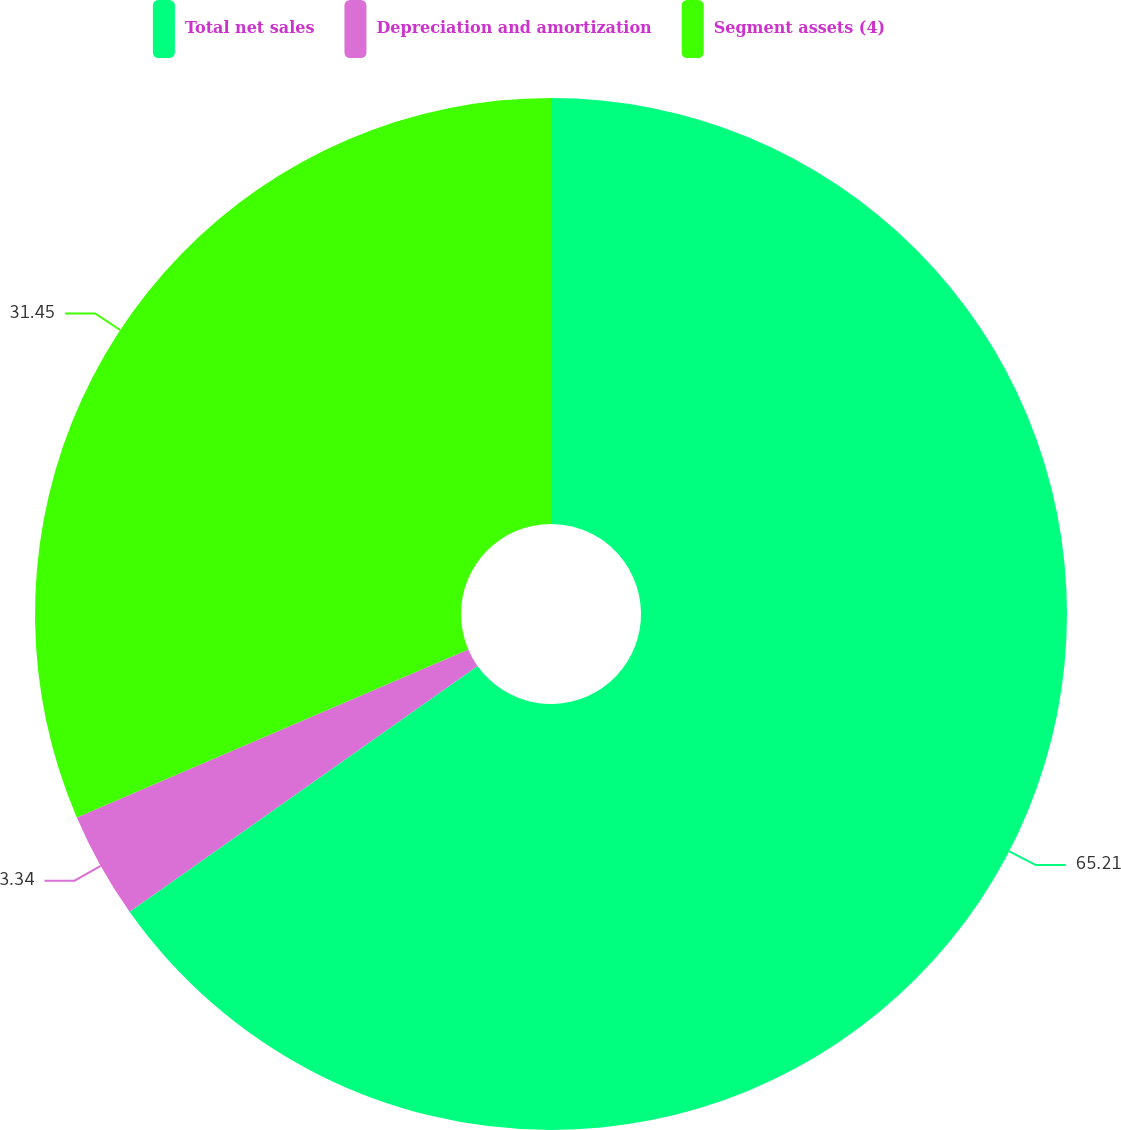<chart> <loc_0><loc_0><loc_500><loc_500><pie_chart><fcel>Total net sales<fcel>Depreciation and amortization<fcel>Segment assets (4)<nl><fcel>65.21%<fcel>3.34%<fcel>31.45%<nl></chart> 